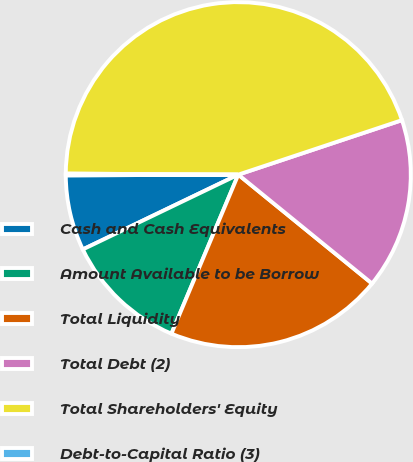<chart> <loc_0><loc_0><loc_500><loc_500><pie_chart><fcel>Cash and Cash Equivalents<fcel>Amount Available to be Borrow<fcel>Total Liquidity<fcel>Total Debt (2)<fcel>Total Shareholders' Equity<fcel>Debt-to-Capital Ratio (3)<nl><fcel>7.07%<fcel>11.53%<fcel>20.46%<fcel>15.99%<fcel>44.79%<fcel>0.16%<nl></chart> 